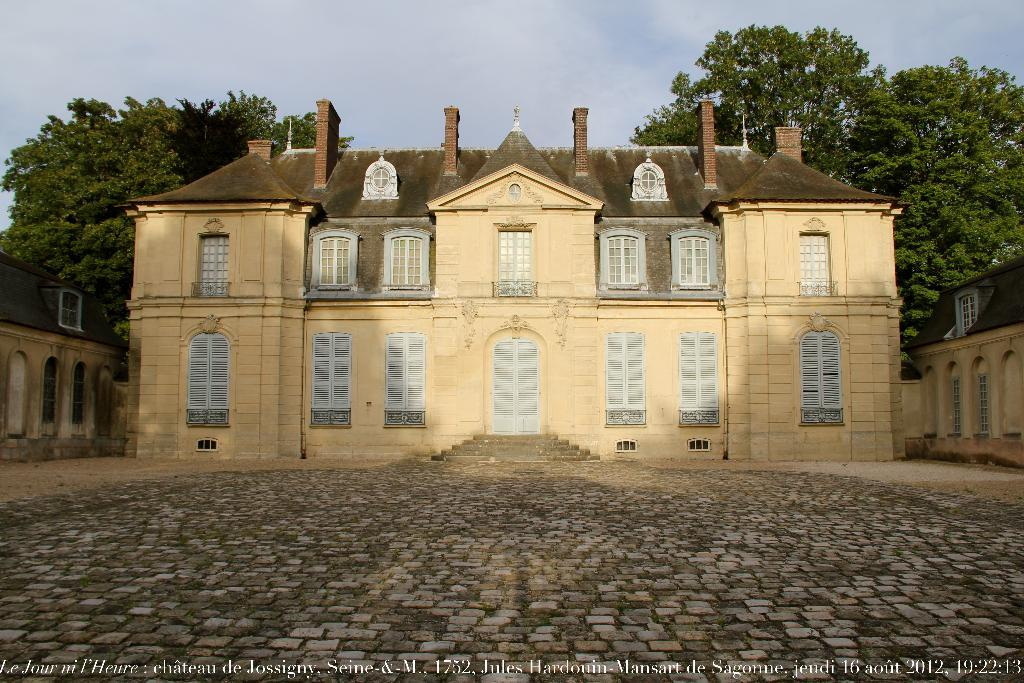What type of flooring is visible in the image? There are tiles on the ground in the image. What structures can be seen in the image? There are buildings in the image. What type of natural elements are present in the background of the image? There are trees in the background of the image. What part of the natural environment is visible in the background of the image? The sky is visible in the background of the image. What is written or displayed at the bottom of the image? There is text at the bottom of the image. Can you see an owl perched on one of the trees in the image? There is no owl present in the image; only trees and the sky are visible in the background. Is there a ghost visible in the image? There is no ghost present in the image. 